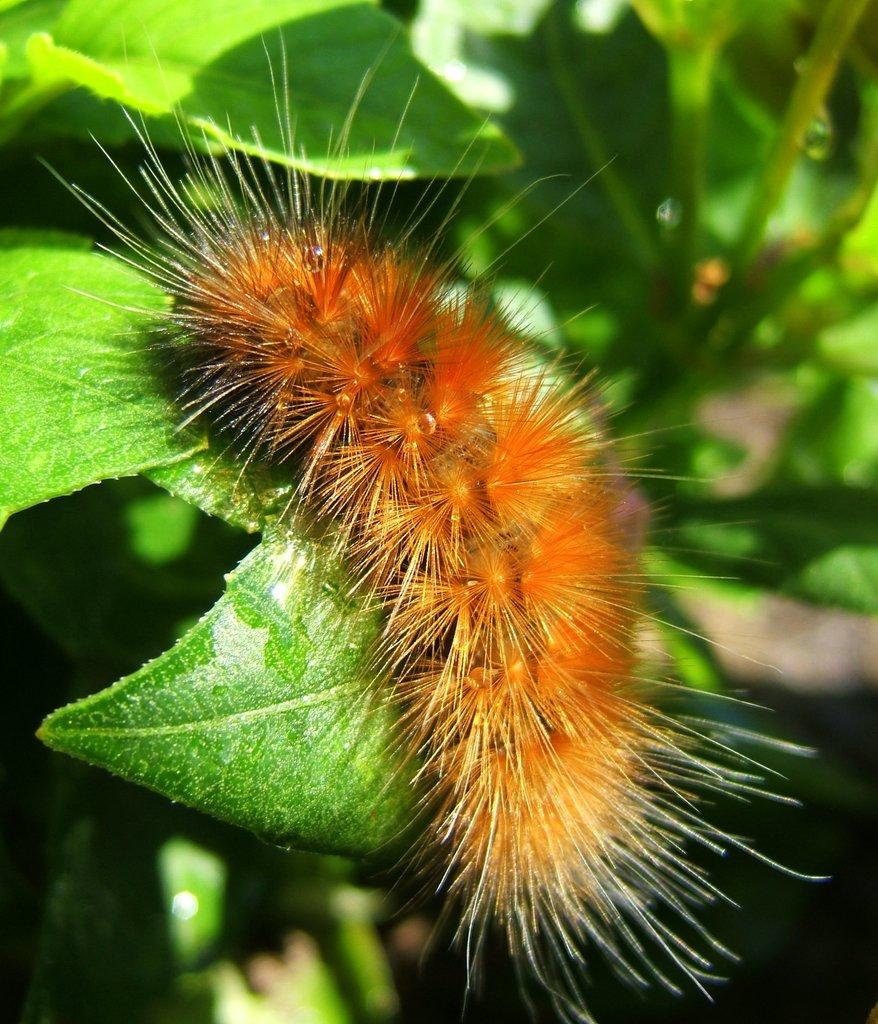What is the main subject in the center of the image? There is an insect in the center of the image. What can be seen in the background of the image? There are plants in the background of the image. What type of tongue can be seen in the image? There is no tongue present in the image; it features an insect and plants in the background. 